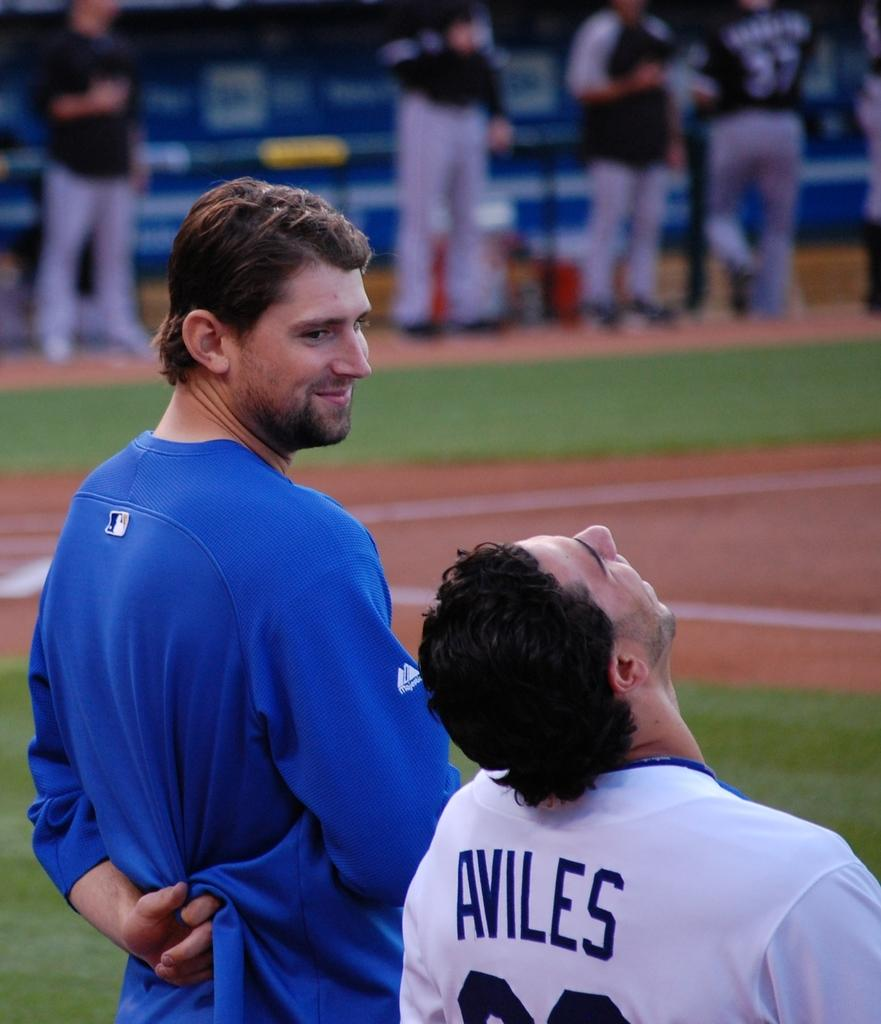<image>
Provide a brief description of the given image. A baseball player named Aviles looks up to the sky as another man gazes at him. 